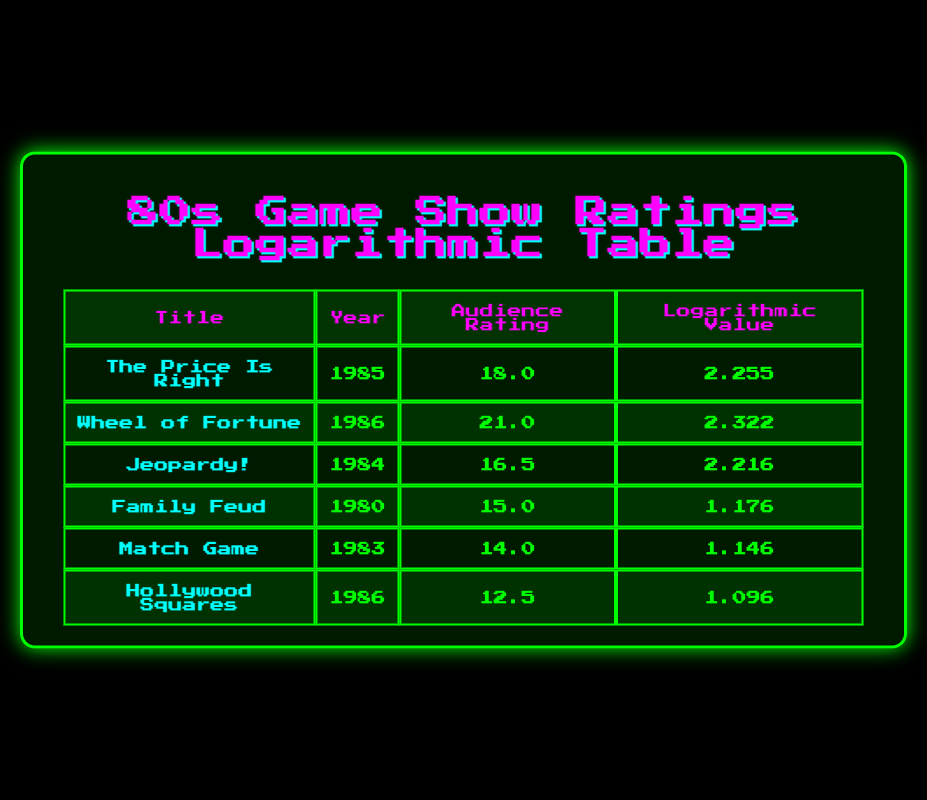What was the highest audience rating among the classic game shows listed? The table lists audience ratings for several classic game shows. The highest rating is 21.0 associated with "Wheel of Fortune" in 1986.
Answer: 21.0 Which show had an audience rating lower than 15? Upon reviewing the table, "Hollywood Squares" has an audience rating of 12.5, which is the only rating below 15.
Answer: Yes How many game shows had audience ratings above 16? Looking at the audience ratings, "The Price Is Right" (18.0), "Wheel of Fortune" (21.0), and "Jeopardy!" (16.5) all have ratings above 16. Thus, there are three shows.
Answer: 3 What is the average audience rating of all the classic game shows listed? To calculate the average, sum all the ratings: 18.0 + 21.0 + 16.5 + 15.0 + 14.0 + 12.5 = 97.0. The number of shows is 6, so the average is 97.0 / 6 = 16.17.
Answer: 16.17 Did "Family Feud" have a higher logarithmic value than "Match Game"? From the table, "Family Feud" has a logarithmic value of 1.176, while "Match Game" has 1.146. Since 1.176 is greater than 1.146, the statement is true.
Answer: Yes What was the year of the game show with the least audience rating? The lowest audience rating is 12.5 for "Hollywood Squares," which aired in 1986. Therefore, the year is 1986.
Answer: 1986 Which two shows had audience ratings that average to exactly 16? The shows "Jeopardy!" (16.5) and "Family Feud" (15.0) can be averaged: (16.5 + 15.0) = 31.5, and divided by 2 results in 15.75, which does not equal 16. Thus, no shows fit this criterion.
Answer: No What is the difference in audience ratings between "The Price Is Right" and "Hollywood Squares"? "The Price Is Right" has an audience rating of 18.0, and "Hollywood Squares" has a rating of 12.5. The difference is calculated as 18.0 - 12.5 = 5.5.
Answer: 5.5 Which game show had a logarithmic value closest to 2.2? Comparing the logarithmic values, "Jeopardy!" (2.216) is the closest to 2.2, as it is very near to that value.
Answer: Jeopardy! 